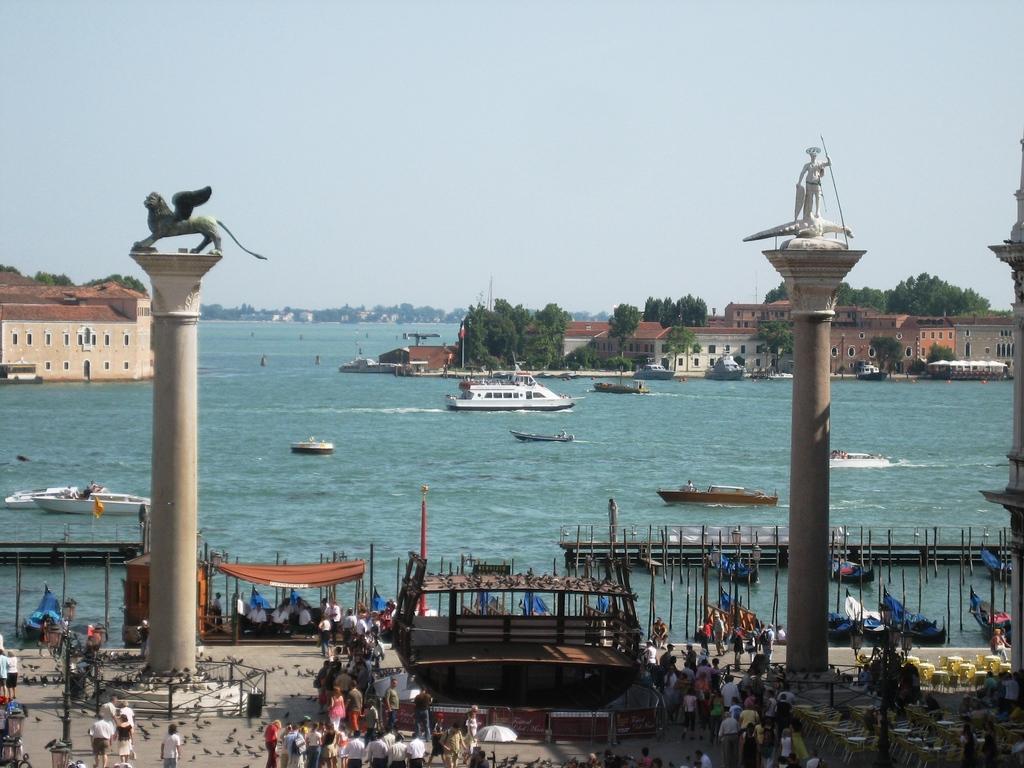In one or two sentences, can you explain what this image depicts? In this picture I can see the buildings and trees. In the center I can see many boats on the water. At the bottom I can see many people were standing near to the boat and fencing. At the top there is a sky. 